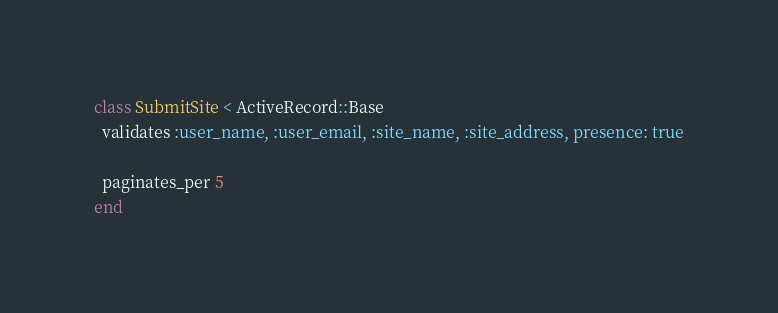<code> <loc_0><loc_0><loc_500><loc_500><_Ruby_>class SubmitSite < ActiveRecord::Base
  validates :user_name, :user_email, :site_name, :site_address, presence: true

  paginates_per 5
end
</code> 